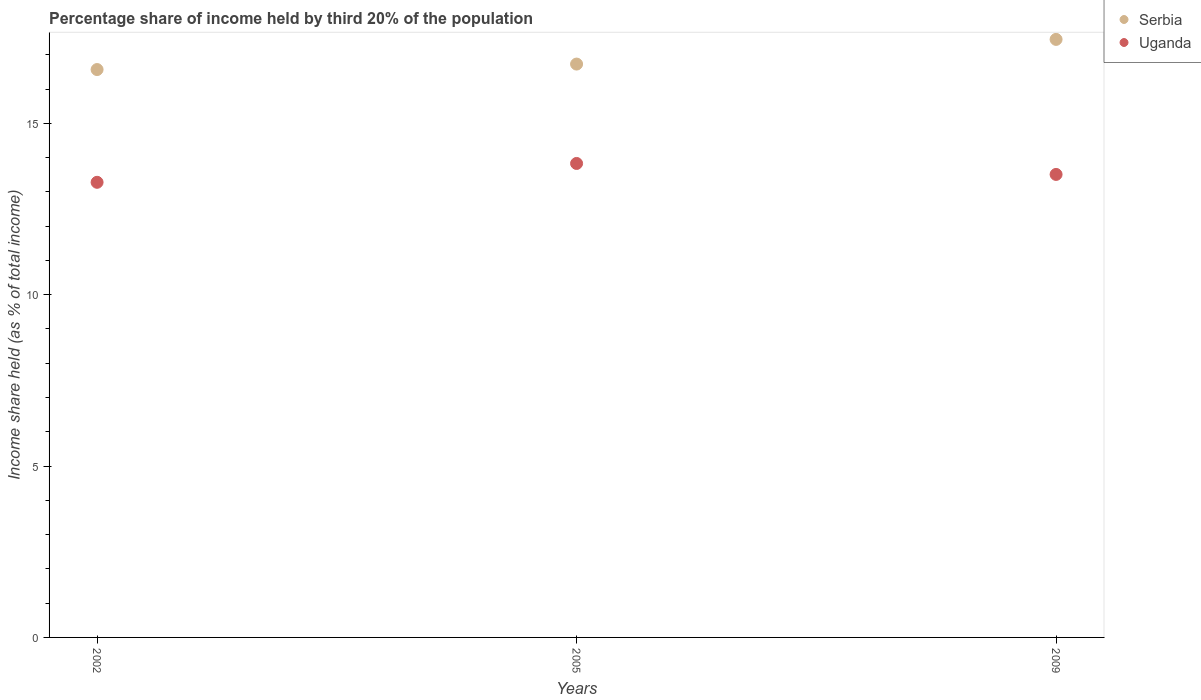Is the number of dotlines equal to the number of legend labels?
Ensure brevity in your answer.  Yes. What is the share of income held by third 20% of the population in Uganda in 2009?
Ensure brevity in your answer.  13.51. Across all years, what is the maximum share of income held by third 20% of the population in Serbia?
Keep it short and to the point. 17.45. Across all years, what is the minimum share of income held by third 20% of the population in Uganda?
Offer a very short reply. 13.28. What is the total share of income held by third 20% of the population in Uganda in the graph?
Your response must be concise. 40.62. What is the difference between the share of income held by third 20% of the population in Serbia in 2002 and that in 2009?
Offer a very short reply. -0.88. What is the difference between the share of income held by third 20% of the population in Uganda in 2005 and the share of income held by third 20% of the population in Serbia in 2009?
Offer a terse response. -3.62. What is the average share of income held by third 20% of the population in Uganda per year?
Make the answer very short. 13.54. In the year 2002, what is the difference between the share of income held by third 20% of the population in Uganda and share of income held by third 20% of the population in Serbia?
Ensure brevity in your answer.  -3.29. What is the ratio of the share of income held by third 20% of the population in Uganda in 2002 to that in 2009?
Offer a terse response. 0.98. Is the difference between the share of income held by third 20% of the population in Uganda in 2005 and 2009 greater than the difference between the share of income held by third 20% of the population in Serbia in 2005 and 2009?
Offer a very short reply. Yes. What is the difference between the highest and the second highest share of income held by third 20% of the population in Uganda?
Offer a very short reply. 0.32. What is the difference between the highest and the lowest share of income held by third 20% of the population in Uganda?
Make the answer very short. 0.55. In how many years, is the share of income held by third 20% of the population in Serbia greater than the average share of income held by third 20% of the population in Serbia taken over all years?
Make the answer very short. 1. Is the sum of the share of income held by third 20% of the population in Serbia in 2002 and 2009 greater than the maximum share of income held by third 20% of the population in Uganda across all years?
Ensure brevity in your answer.  Yes. Is the share of income held by third 20% of the population in Serbia strictly greater than the share of income held by third 20% of the population in Uganda over the years?
Your answer should be compact. Yes. Are the values on the major ticks of Y-axis written in scientific E-notation?
Offer a terse response. No. Does the graph contain grids?
Your response must be concise. No. Where does the legend appear in the graph?
Offer a very short reply. Top right. How are the legend labels stacked?
Provide a short and direct response. Vertical. What is the title of the graph?
Provide a succinct answer. Percentage share of income held by third 20% of the population. What is the label or title of the X-axis?
Offer a very short reply. Years. What is the label or title of the Y-axis?
Make the answer very short. Income share held (as % of total income). What is the Income share held (as % of total income) in Serbia in 2002?
Provide a short and direct response. 16.57. What is the Income share held (as % of total income) in Uganda in 2002?
Keep it short and to the point. 13.28. What is the Income share held (as % of total income) in Serbia in 2005?
Provide a succinct answer. 16.73. What is the Income share held (as % of total income) of Uganda in 2005?
Make the answer very short. 13.83. What is the Income share held (as % of total income) of Serbia in 2009?
Ensure brevity in your answer.  17.45. What is the Income share held (as % of total income) of Uganda in 2009?
Make the answer very short. 13.51. Across all years, what is the maximum Income share held (as % of total income) of Serbia?
Your answer should be very brief. 17.45. Across all years, what is the maximum Income share held (as % of total income) of Uganda?
Your answer should be compact. 13.83. Across all years, what is the minimum Income share held (as % of total income) of Serbia?
Make the answer very short. 16.57. Across all years, what is the minimum Income share held (as % of total income) of Uganda?
Your answer should be very brief. 13.28. What is the total Income share held (as % of total income) in Serbia in the graph?
Give a very brief answer. 50.75. What is the total Income share held (as % of total income) in Uganda in the graph?
Ensure brevity in your answer.  40.62. What is the difference between the Income share held (as % of total income) of Serbia in 2002 and that in 2005?
Keep it short and to the point. -0.16. What is the difference between the Income share held (as % of total income) of Uganda in 2002 and that in 2005?
Your response must be concise. -0.55. What is the difference between the Income share held (as % of total income) in Serbia in 2002 and that in 2009?
Your answer should be very brief. -0.88. What is the difference between the Income share held (as % of total income) of Uganda in 2002 and that in 2009?
Offer a terse response. -0.23. What is the difference between the Income share held (as % of total income) of Serbia in 2005 and that in 2009?
Ensure brevity in your answer.  -0.72. What is the difference between the Income share held (as % of total income) in Uganda in 2005 and that in 2009?
Provide a short and direct response. 0.32. What is the difference between the Income share held (as % of total income) of Serbia in 2002 and the Income share held (as % of total income) of Uganda in 2005?
Your answer should be very brief. 2.74. What is the difference between the Income share held (as % of total income) in Serbia in 2002 and the Income share held (as % of total income) in Uganda in 2009?
Your response must be concise. 3.06. What is the difference between the Income share held (as % of total income) of Serbia in 2005 and the Income share held (as % of total income) of Uganda in 2009?
Make the answer very short. 3.22. What is the average Income share held (as % of total income) in Serbia per year?
Your answer should be compact. 16.92. What is the average Income share held (as % of total income) of Uganda per year?
Provide a short and direct response. 13.54. In the year 2002, what is the difference between the Income share held (as % of total income) of Serbia and Income share held (as % of total income) of Uganda?
Ensure brevity in your answer.  3.29. In the year 2005, what is the difference between the Income share held (as % of total income) of Serbia and Income share held (as % of total income) of Uganda?
Offer a terse response. 2.9. In the year 2009, what is the difference between the Income share held (as % of total income) in Serbia and Income share held (as % of total income) in Uganda?
Give a very brief answer. 3.94. What is the ratio of the Income share held (as % of total income) in Serbia in 2002 to that in 2005?
Provide a short and direct response. 0.99. What is the ratio of the Income share held (as % of total income) in Uganda in 2002 to that in 2005?
Provide a succinct answer. 0.96. What is the ratio of the Income share held (as % of total income) in Serbia in 2002 to that in 2009?
Keep it short and to the point. 0.95. What is the ratio of the Income share held (as % of total income) of Serbia in 2005 to that in 2009?
Your answer should be compact. 0.96. What is the ratio of the Income share held (as % of total income) of Uganda in 2005 to that in 2009?
Offer a terse response. 1.02. What is the difference between the highest and the second highest Income share held (as % of total income) in Serbia?
Provide a succinct answer. 0.72. What is the difference between the highest and the second highest Income share held (as % of total income) of Uganda?
Your answer should be compact. 0.32. What is the difference between the highest and the lowest Income share held (as % of total income) in Uganda?
Provide a short and direct response. 0.55. 